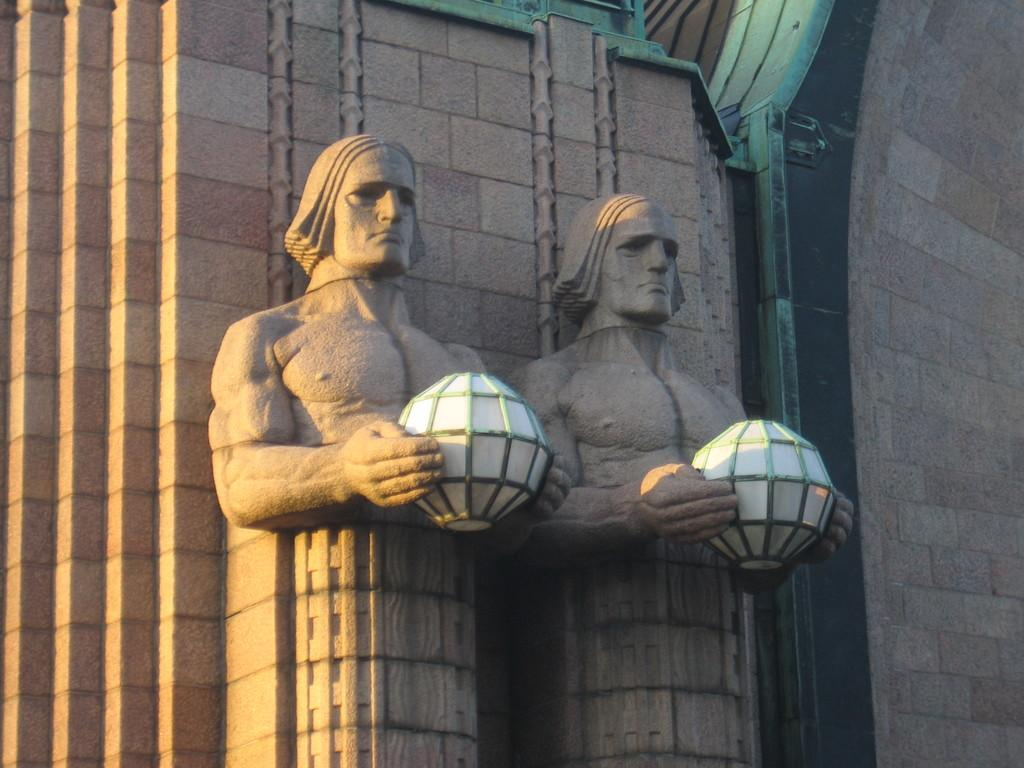How many statues are present in the image? There are two statues in the image. What are the statues holding in their hands? The statues are holding some object. What is the color of the background wall in the image? The background wall is in brown color. What type of car can be seen parked next to the statues in the image? There is no car present in the image; it only features two statues and a background wall. What type of army uniforms are the statues wearing in the image? The statues are not wearing any army uniforms, as the image only shows the statues holding an object and the brown background wall. 